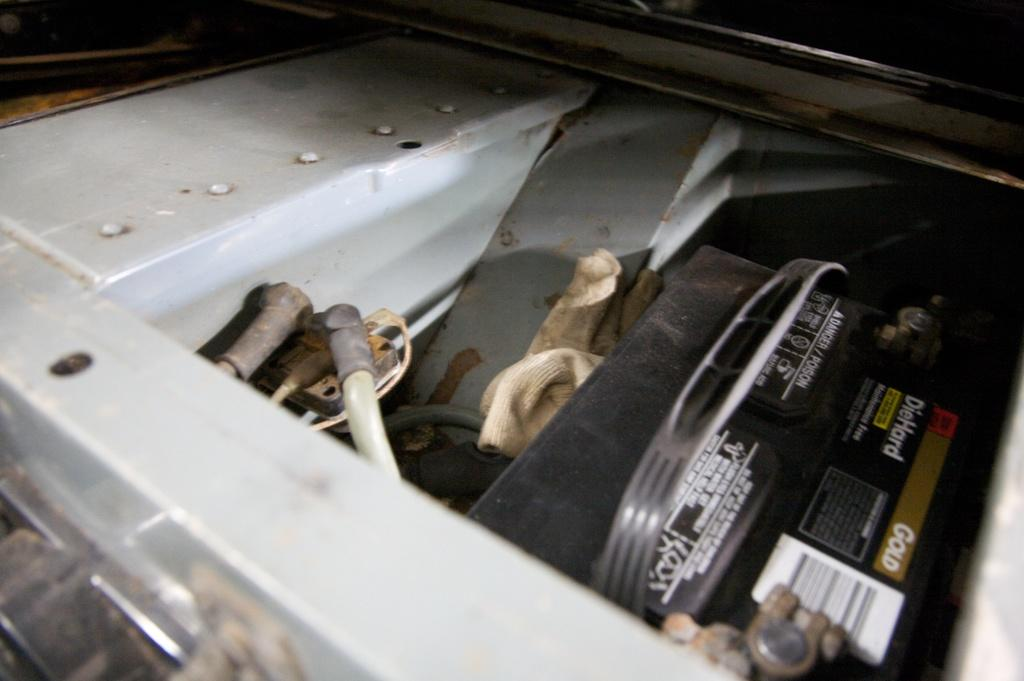What is the color of the main object in the image? The main object in the image is white. What can be found inside the white object? The white object contains some rods. Is there any other color object in the image? Yes, there is a black color object in the image. Can you tell me how the stranger and governor are interacting in the image? There is no stranger or governor present in the image; it only contains a white object with rods and a black object. 